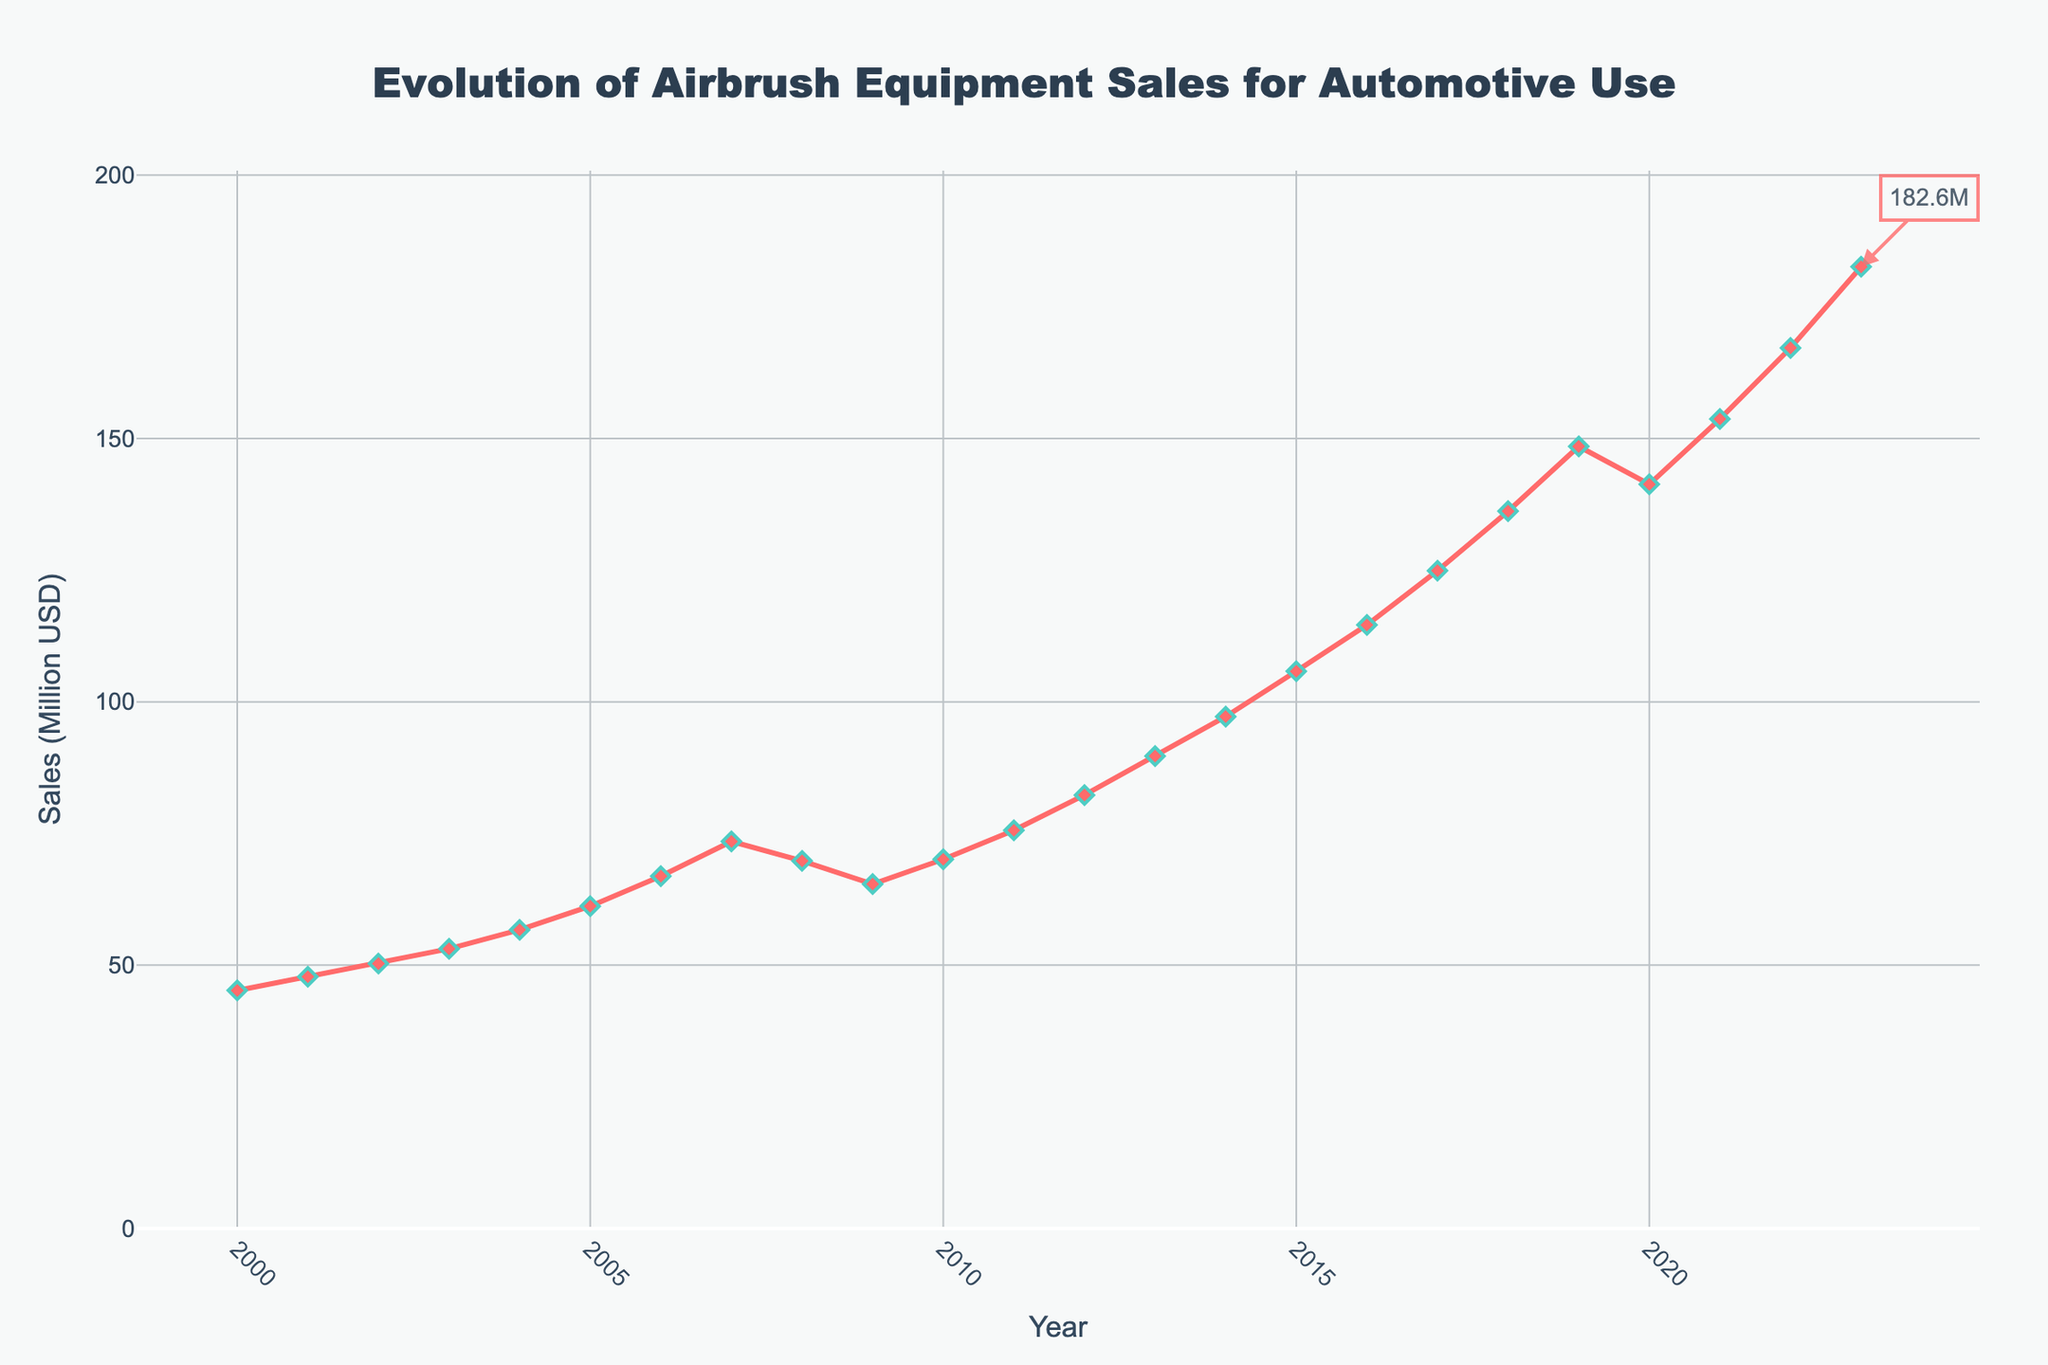What is the general trend in airbrush equipment sales for automotive use from 2000 to 2023? The trend shows a general increase in sales from 2000 to 2023, with a few dips, mainly around 2008-2009 and 2020.
Answer: Increasing trend In which year did sales first exceed 100 million USD? Sales first exceeded 100 million USD in 2015.
Answer: 2015 How much did sales increase from 2005 to 2010? The sales in 2005 were 61.2 million USD, and in 2010 they were 70.1 million USD. The increase is 70.1 - 61.2 = 8.9 million USD.
Answer: 8.9 million USD Which year experienced the highest sales and what was the value? The highest sales were in 2023 with a value of 182.6 million USD.
Answer: 2023, 182.6 million USD Identify the period with the largest decline in sales. The largest decline in sales occurred between 2007 and 2009 where sales dropped from 73.5 million USD to 65.4 million USD.
Answer: 2007-2009 What is the average annual sales over the entire period? To find the average, sum all sales values and divide by the number of years: (45.2+47.8+50.3+53.1+56.7+61.2+66.9+73.5+69.8+65.4+70.1+75.6+82.3+89.7+97.2+105.8+114.6+124.9+136.2+148.5+141.3+153.7+167.2+182.6)/24 ≈ 92.6 million USD.
Answer: 92.6 million USD By how much did sales decline during the 2008 financial crisis? Sales declined from 73.5 million USD in 2007 to 65.4 million USD in 2009, a decline of 73.5 - 65.4 = 8.1 million USD.
Answer: 8.1 million USD Compare the sales growth between the periods 2000-2010 and 2010-2020. Which period had greater growth? From 2000 to 2010, sales increased from 45.2 million USD to 70.1 million USD, a growth of 24.9 million USD. From 2010 to 2020, sales increased from 70.1 million USD to 141.3 million USD, a growth of 71.2 million USD. The period 2010-2020 had greater growth.
Answer: 2010-2020 What is the median sales value over the entire period? To find the median, list sales values in ascending order and find the middle value. Median for 24 values is the average of 12th and 13th values: (75.6 + 82.3)/2 = 78.95 million USD.
Answer: 78.95 million USD 